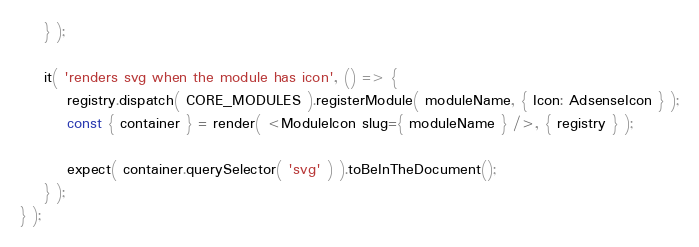Convert code to text. <code><loc_0><loc_0><loc_500><loc_500><_JavaScript_>	} );

	it( 'renders svg when the module has icon', () => {
		registry.dispatch( CORE_MODULES ).registerModule( moduleName, { Icon: AdsenseIcon } );
		const { container } = render( <ModuleIcon slug={ moduleName } />, { registry } );

		expect( container.querySelector( 'svg' ) ).toBeInTheDocument();
	} );
} );
</code> 